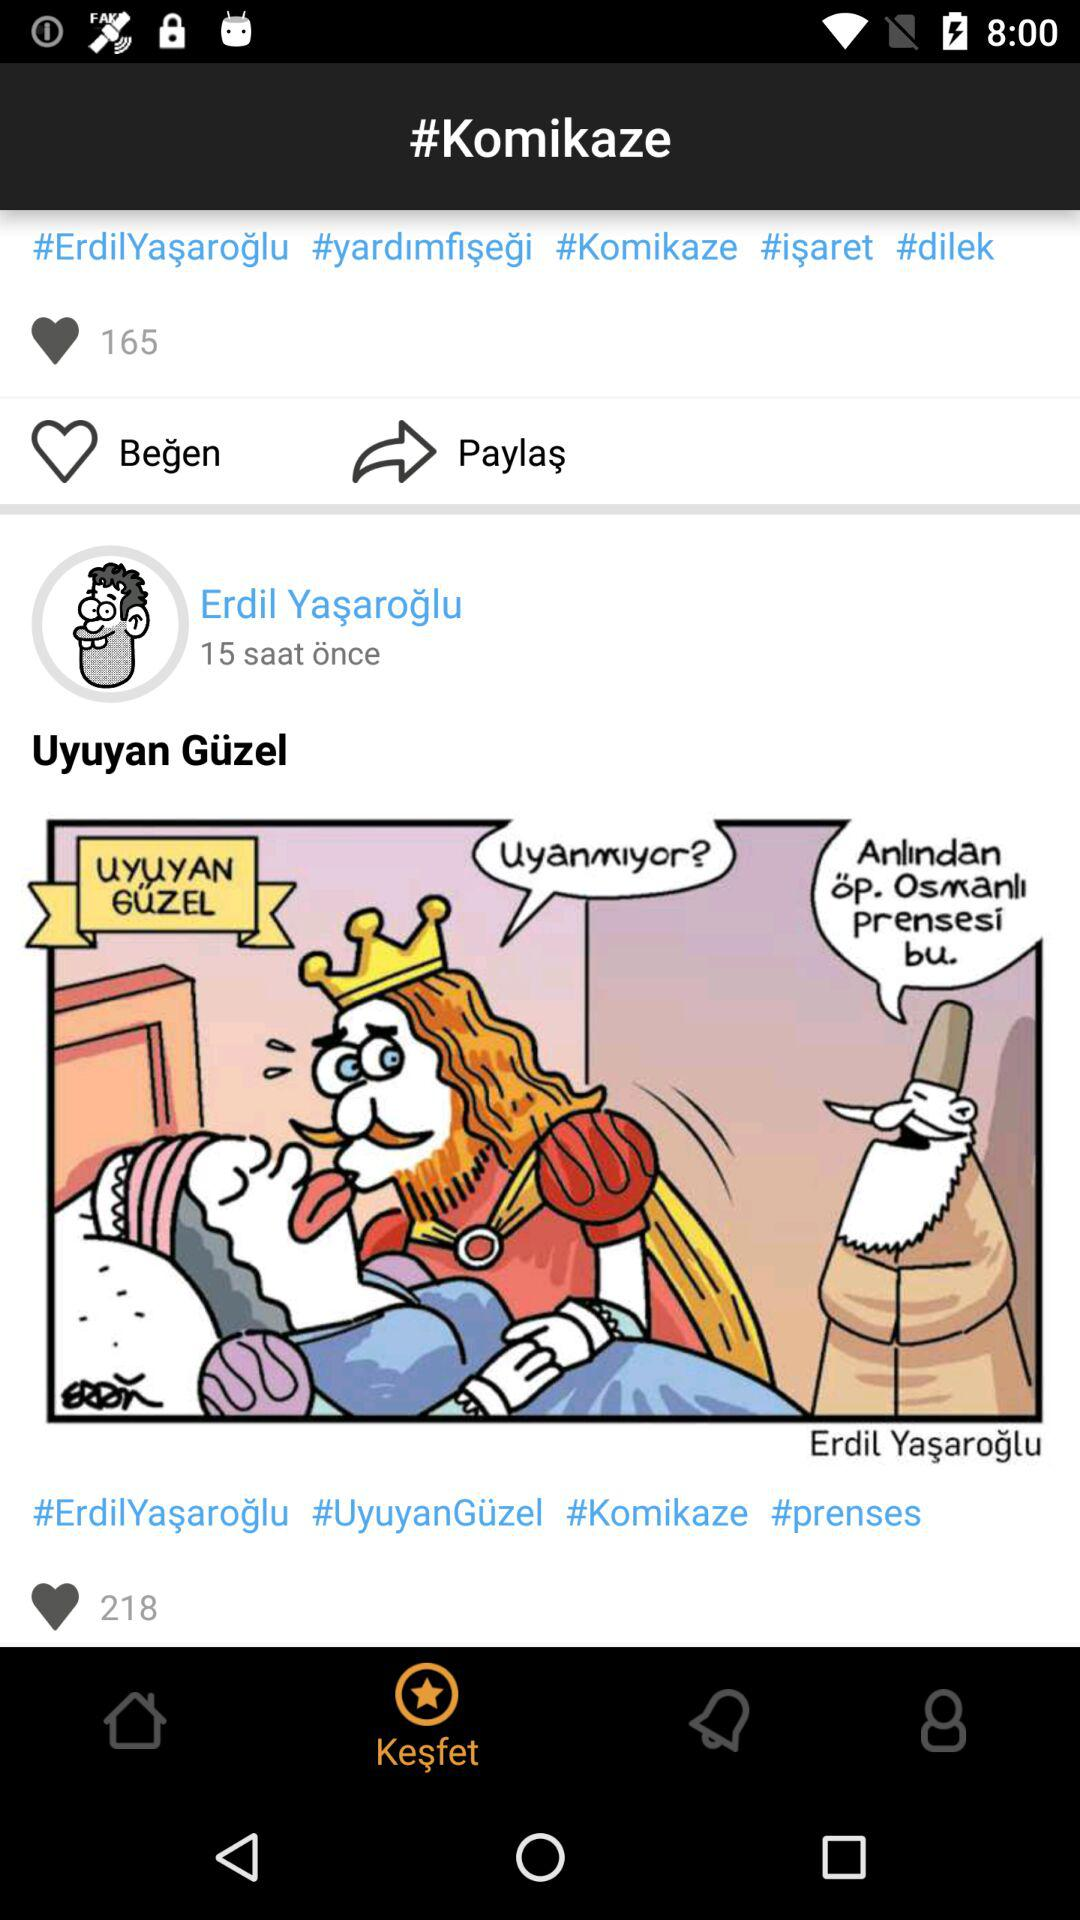How many hashtags are there in the first post?
Answer the question using a single word or phrase. 5 